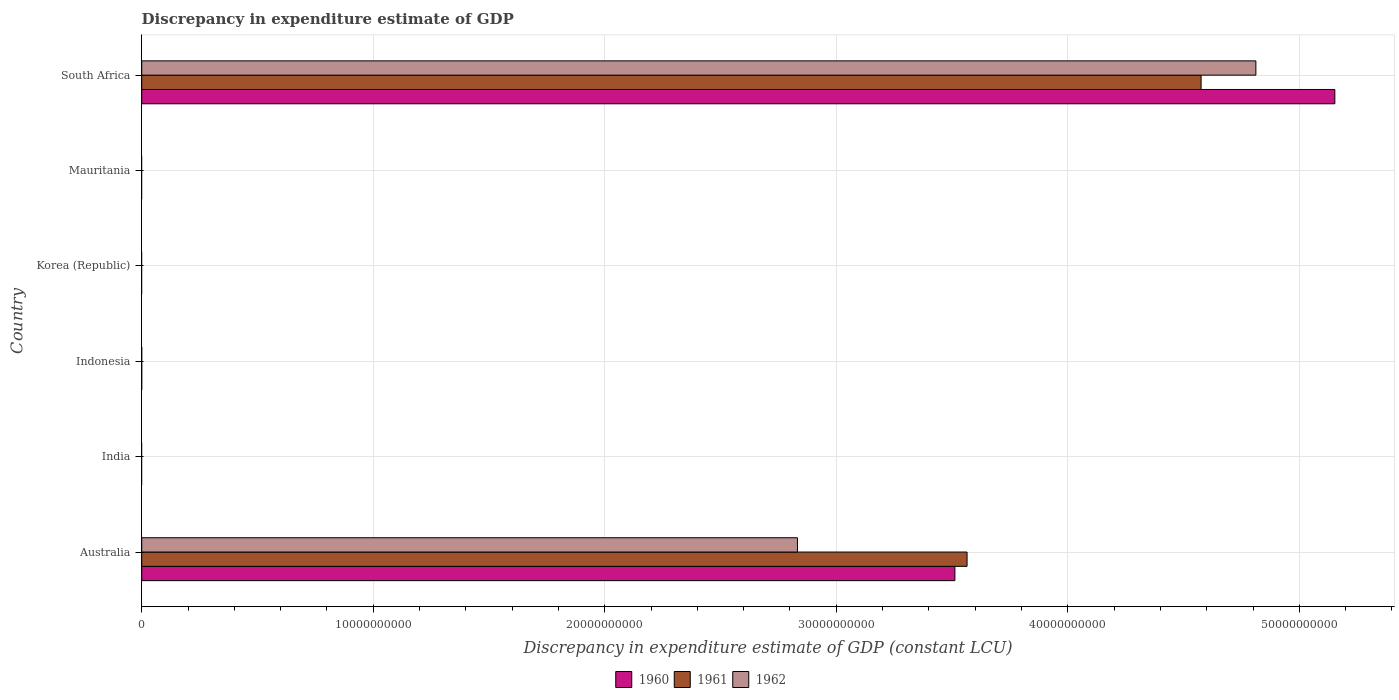Are the number of bars per tick equal to the number of legend labels?
Your answer should be compact. No. Are the number of bars on each tick of the Y-axis equal?
Your answer should be compact. No. How many bars are there on the 6th tick from the top?
Provide a succinct answer. 3. How many bars are there on the 3rd tick from the bottom?
Your answer should be very brief. 0. What is the label of the 2nd group of bars from the top?
Make the answer very short. Mauritania. In how many cases, is the number of bars for a given country not equal to the number of legend labels?
Your answer should be compact. 4. What is the discrepancy in expenditure estimate of GDP in 1962 in Korea (Republic)?
Give a very brief answer. 0. Across all countries, what is the maximum discrepancy in expenditure estimate of GDP in 1961?
Offer a very short reply. 4.58e+1. Across all countries, what is the minimum discrepancy in expenditure estimate of GDP in 1960?
Provide a succinct answer. 0. In which country was the discrepancy in expenditure estimate of GDP in 1960 maximum?
Your answer should be very brief. South Africa. What is the total discrepancy in expenditure estimate of GDP in 1960 in the graph?
Provide a succinct answer. 8.67e+1. What is the difference between the discrepancy in expenditure estimate of GDP in 1961 in Australia and that in South Africa?
Keep it short and to the point. -1.01e+1. What is the difference between the discrepancy in expenditure estimate of GDP in 1962 in Mauritania and the discrepancy in expenditure estimate of GDP in 1960 in Indonesia?
Make the answer very short. 0. What is the average discrepancy in expenditure estimate of GDP in 1960 per country?
Your answer should be very brief. 1.44e+1. What is the difference between the discrepancy in expenditure estimate of GDP in 1961 and discrepancy in expenditure estimate of GDP in 1960 in South Africa?
Provide a short and direct response. -5.78e+09. In how many countries, is the discrepancy in expenditure estimate of GDP in 1961 greater than 26000000000 LCU?
Keep it short and to the point. 2. What is the ratio of the discrepancy in expenditure estimate of GDP in 1961 in Australia to that in South Africa?
Make the answer very short. 0.78. What is the difference between the highest and the lowest discrepancy in expenditure estimate of GDP in 1961?
Provide a short and direct response. 4.58e+1. Is it the case that in every country, the sum of the discrepancy in expenditure estimate of GDP in 1961 and discrepancy in expenditure estimate of GDP in 1962 is greater than the discrepancy in expenditure estimate of GDP in 1960?
Offer a very short reply. No. How many bars are there?
Offer a very short reply. 6. Are all the bars in the graph horizontal?
Your answer should be very brief. Yes. Does the graph contain any zero values?
Give a very brief answer. Yes. How many legend labels are there?
Ensure brevity in your answer.  3. What is the title of the graph?
Your answer should be compact. Discrepancy in expenditure estimate of GDP. Does "1964" appear as one of the legend labels in the graph?
Provide a short and direct response. No. What is the label or title of the X-axis?
Your answer should be very brief. Discrepancy in expenditure estimate of GDP (constant LCU). What is the Discrepancy in expenditure estimate of GDP (constant LCU) of 1960 in Australia?
Your answer should be very brief. 3.51e+1. What is the Discrepancy in expenditure estimate of GDP (constant LCU) in 1961 in Australia?
Offer a terse response. 3.56e+1. What is the Discrepancy in expenditure estimate of GDP (constant LCU) of 1962 in Australia?
Your answer should be very brief. 2.83e+1. What is the Discrepancy in expenditure estimate of GDP (constant LCU) in 1961 in Indonesia?
Keep it short and to the point. 0. What is the Discrepancy in expenditure estimate of GDP (constant LCU) of 1960 in Mauritania?
Give a very brief answer. 0. What is the Discrepancy in expenditure estimate of GDP (constant LCU) of 1961 in Mauritania?
Your answer should be compact. 0. What is the Discrepancy in expenditure estimate of GDP (constant LCU) of 1960 in South Africa?
Give a very brief answer. 5.15e+1. What is the Discrepancy in expenditure estimate of GDP (constant LCU) of 1961 in South Africa?
Keep it short and to the point. 4.58e+1. What is the Discrepancy in expenditure estimate of GDP (constant LCU) of 1962 in South Africa?
Provide a short and direct response. 4.81e+1. Across all countries, what is the maximum Discrepancy in expenditure estimate of GDP (constant LCU) of 1960?
Make the answer very short. 5.15e+1. Across all countries, what is the maximum Discrepancy in expenditure estimate of GDP (constant LCU) in 1961?
Provide a short and direct response. 4.58e+1. Across all countries, what is the maximum Discrepancy in expenditure estimate of GDP (constant LCU) of 1962?
Offer a very short reply. 4.81e+1. Across all countries, what is the minimum Discrepancy in expenditure estimate of GDP (constant LCU) of 1960?
Offer a very short reply. 0. Across all countries, what is the minimum Discrepancy in expenditure estimate of GDP (constant LCU) in 1961?
Keep it short and to the point. 0. What is the total Discrepancy in expenditure estimate of GDP (constant LCU) in 1960 in the graph?
Provide a short and direct response. 8.67e+1. What is the total Discrepancy in expenditure estimate of GDP (constant LCU) in 1961 in the graph?
Your response must be concise. 8.14e+1. What is the total Discrepancy in expenditure estimate of GDP (constant LCU) of 1962 in the graph?
Provide a short and direct response. 7.64e+1. What is the difference between the Discrepancy in expenditure estimate of GDP (constant LCU) of 1960 in Australia and that in South Africa?
Keep it short and to the point. -1.64e+1. What is the difference between the Discrepancy in expenditure estimate of GDP (constant LCU) of 1961 in Australia and that in South Africa?
Give a very brief answer. -1.01e+1. What is the difference between the Discrepancy in expenditure estimate of GDP (constant LCU) of 1962 in Australia and that in South Africa?
Your answer should be very brief. -1.98e+1. What is the difference between the Discrepancy in expenditure estimate of GDP (constant LCU) of 1960 in Australia and the Discrepancy in expenditure estimate of GDP (constant LCU) of 1961 in South Africa?
Make the answer very short. -1.06e+1. What is the difference between the Discrepancy in expenditure estimate of GDP (constant LCU) of 1960 in Australia and the Discrepancy in expenditure estimate of GDP (constant LCU) of 1962 in South Africa?
Make the answer very short. -1.30e+1. What is the difference between the Discrepancy in expenditure estimate of GDP (constant LCU) of 1961 in Australia and the Discrepancy in expenditure estimate of GDP (constant LCU) of 1962 in South Africa?
Offer a terse response. -1.25e+1. What is the average Discrepancy in expenditure estimate of GDP (constant LCU) of 1960 per country?
Give a very brief answer. 1.44e+1. What is the average Discrepancy in expenditure estimate of GDP (constant LCU) in 1961 per country?
Keep it short and to the point. 1.36e+1. What is the average Discrepancy in expenditure estimate of GDP (constant LCU) in 1962 per country?
Offer a terse response. 1.27e+1. What is the difference between the Discrepancy in expenditure estimate of GDP (constant LCU) in 1960 and Discrepancy in expenditure estimate of GDP (constant LCU) in 1961 in Australia?
Make the answer very short. -5.25e+08. What is the difference between the Discrepancy in expenditure estimate of GDP (constant LCU) of 1960 and Discrepancy in expenditure estimate of GDP (constant LCU) of 1962 in Australia?
Keep it short and to the point. 6.80e+09. What is the difference between the Discrepancy in expenditure estimate of GDP (constant LCU) of 1961 and Discrepancy in expenditure estimate of GDP (constant LCU) of 1962 in Australia?
Keep it short and to the point. 7.33e+09. What is the difference between the Discrepancy in expenditure estimate of GDP (constant LCU) in 1960 and Discrepancy in expenditure estimate of GDP (constant LCU) in 1961 in South Africa?
Offer a terse response. 5.78e+09. What is the difference between the Discrepancy in expenditure estimate of GDP (constant LCU) in 1960 and Discrepancy in expenditure estimate of GDP (constant LCU) in 1962 in South Africa?
Keep it short and to the point. 3.41e+09. What is the difference between the Discrepancy in expenditure estimate of GDP (constant LCU) of 1961 and Discrepancy in expenditure estimate of GDP (constant LCU) of 1962 in South Africa?
Offer a terse response. -2.37e+09. What is the ratio of the Discrepancy in expenditure estimate of GDP (constant LCU) in 1960 in Australia to that in South Africa?
Give a very brief answer. 0.68. What is the ratio of the Discrepancy in expenditure estimate of GDP (constant LCU) of 1961 in Australia to that in South Africa?
Your answer should be very brief. 0.78. What is the ratio of the Discrepancy in expenditure estimate of GDP (constant LCU) in 1962 in Australia to that in South Africa?
Keep it short and to the point. 0.59. What is the difference between the highest and the lowest Discrepancy in expenditure estimate of GDP (constant LCU) of 1960?
Ensure brevity in your answer.  5.15e+1. What is the difference between the highest and the lowest Discrepancy in expenditure estimate of GDP (constant LCU) in 1961?
Your answer should be compact. 4.58e+1. What is the difference between the highest and the lowest Discrepancy in expenditure estimate of GDP (constant LCU) of 1962?
Give a very brief answer. 4.81e+1. 